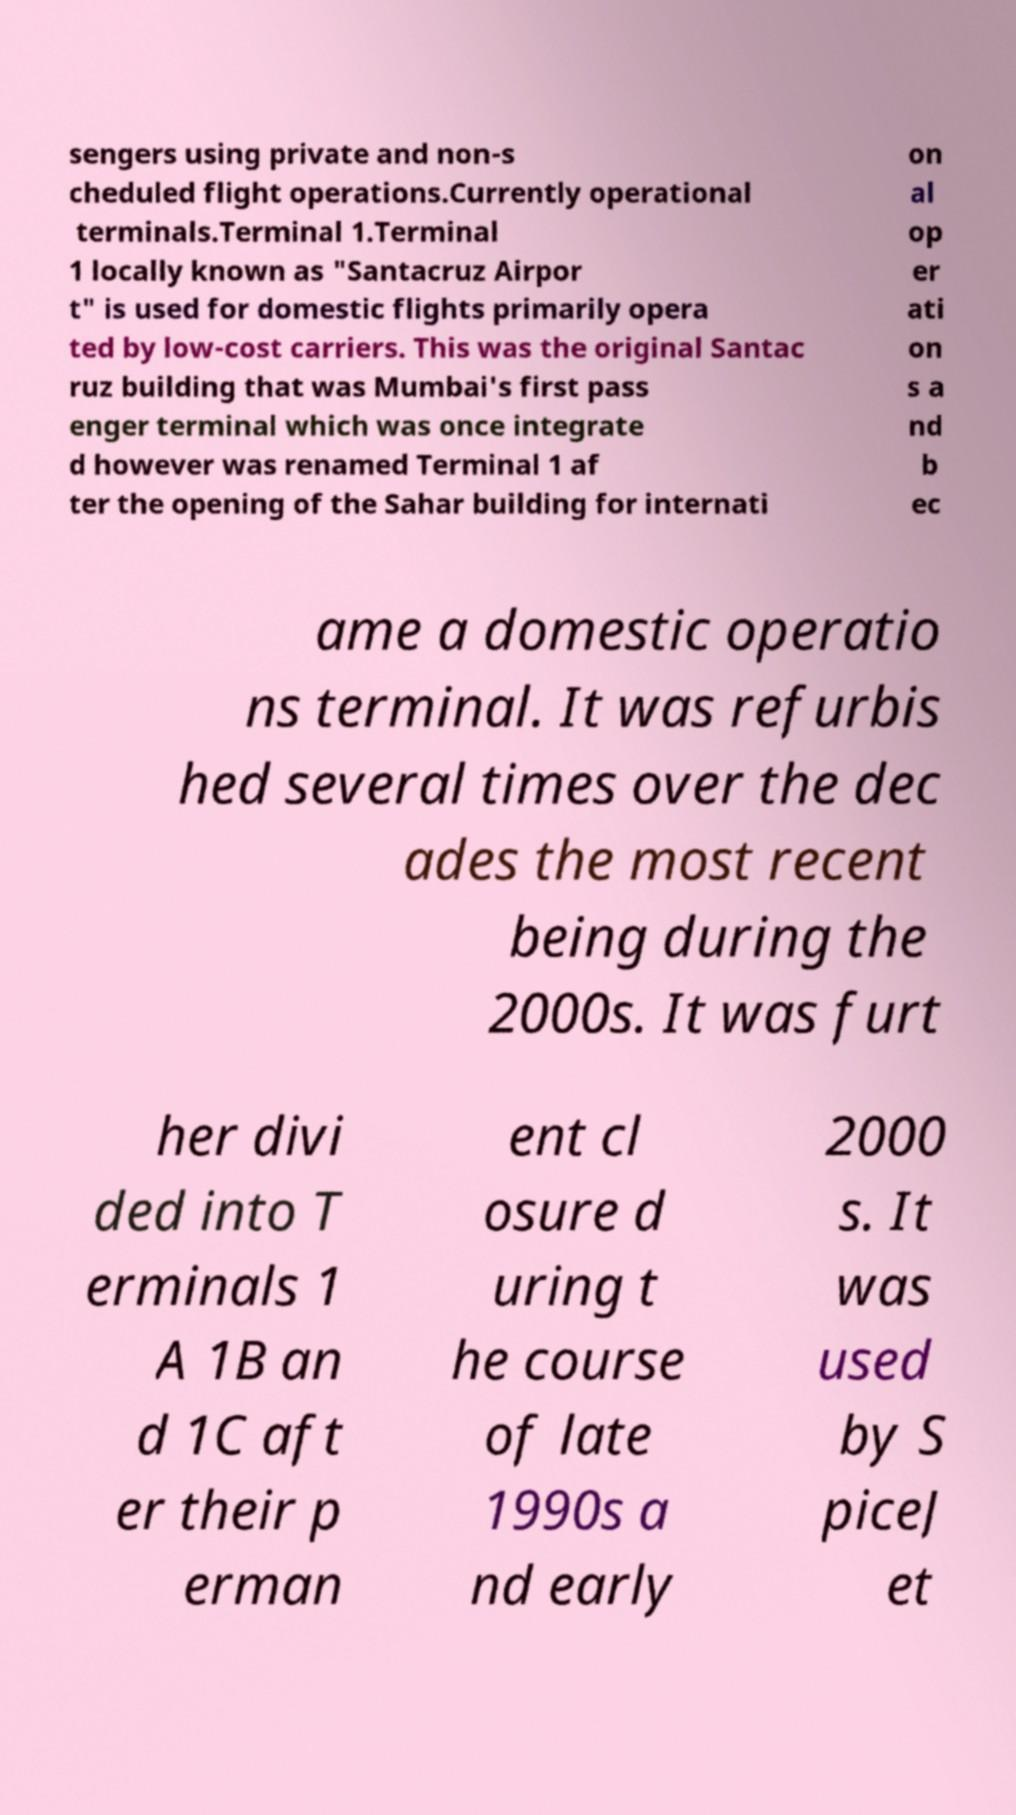Could you assist in decoding the text presented in this image and type it out clearly? sengers using private and non-s cheduled flight operations.Currently operational terminals.Terminal 1.Terminal 1 locally known as "Santacruz Airpor t" is used for domestic flights primarily opera ted by low-cost carriers. This was the original Santac ruz building that was Mumbai's first pass enger terminal which was once integrate d however was renamed Terminal 1 af ter the opening of the Sahar building for internati on al op er ati on s a nd b ec ame a domestic operatio ns terminal. It was refurbis hed several times over the dec ades the most recent being during the 2000s. It was furt her divi ded into T erminals 1 A 1B an d 1C aft er their p erman ent cl osure d uring t he course of late 1990s a nd early 2000 s. It was used by S piceJ et 